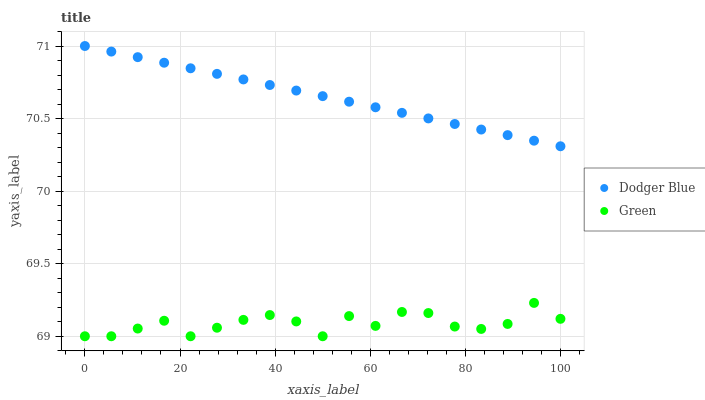Does Green have the minimum area under the curve?
Answer yes or no. Yes. Does Dodger Blue have the maximum area under the curve?
Answer yes or no. Yes. Does Dodger Blue have the minimum area under the curve?
Answer yes or no. No. Is Dodger Blue the smoothest?
Answer yes or no. Yes. Is Green the roughest?
Answer yes or no. Yes. Is Dodger Blue the roughest?
Answer yes or no. No. Does Green have the lowest value?
Answer yes or no. Yes. Does Dodger Blue have the lowest value?
Answer yes or no. No. Does Dodger Blue have the highest value?
Answer yes or no. Yes. Is Green less than Dodger Blue?
Answer yes or no. Yes. Is Dodger Blue greater than Green?
Answer yes or no. Yes. Does Green intersect Dodger Blue?
Answer yes or no. No. 